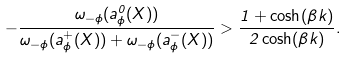Convert formula to latex. <formula><loc_0><loc_0><loc_500><loc_500>- \frac { \omega _ { - \phi } ( a _ { \phi } ^ { 0 } ( X ) ) } { \omega _ { - \phi } ( a _ { \phi } ^ { + } ( X ) ) + \omega _ { - \phi } ( a _ { \phi } ^ { - } ( X ) ) } > \frac { 1 + \cosh ( \beta k ) } { 2 \cosh ( \beta k ) } .</formula> 